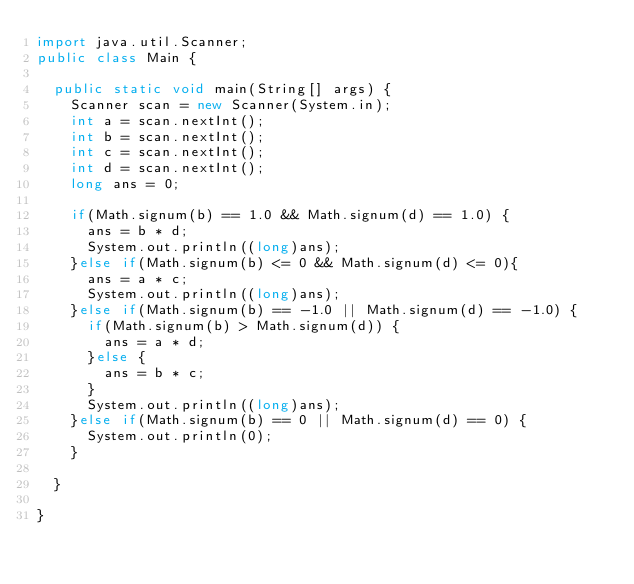Convert code to text. <code><loc_0><loc_0><loc_500><loc_500><_Java_>import java.util.Scanner;
public class Main {

	public static void main(String[] args) {
		Scanner scan = new Scanner(System.in);
		int a = scan.nextInt();
		int b = scan.nextInt();
		int c = scan.nextInt();
		int d = scan.nextInt();
		long ans = 0;
		
		if(Math.signum(b) == 1.0 && Math.signum(d) == 1.0) {
			ans = b * d;
			System.out.println((long)ans);
		}else if(Math.signum(b) <= 0 && Math.signum(d) <= 0){
			ans = a * c;
			System.out.println((long)ans);
		}else if(Math.signum(b) == -1.0 || Math.signum(d) == -1.0) {
			if(Math.signum(b) > Math.signum(d)) {
				ans = a * d;
			}else {
				ans = b * c;
			}
			System.out.println((long)ans);
		}else if(Math.signum(b) == 0 || Math.signum(d) == 0) {
			System.out.println(0);
		}

	}

}
</code> 